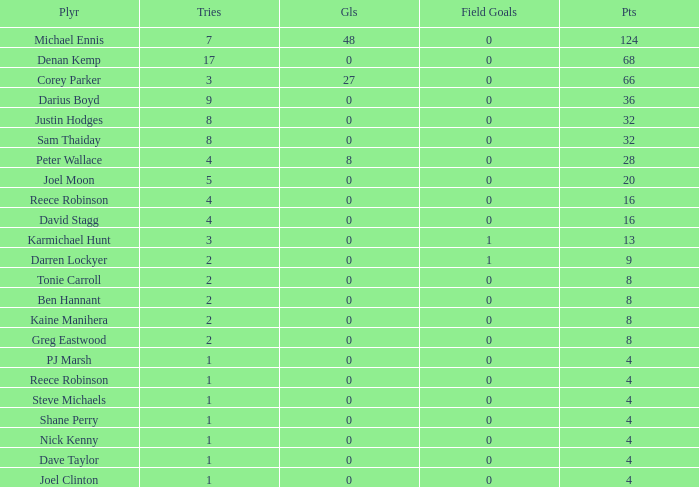What is the minimum number of attempts for a player with over 0 goals, 28 points, and more than 0 field goals? None. 